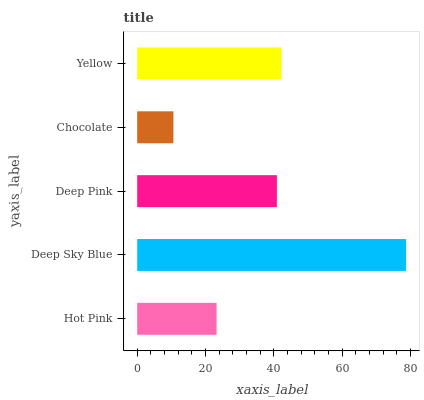Is Chocolate the minimum?
Answer yes or no. Yes. Is Deep Sky Blue the maximum?
Answer yes or no. Yes. Is Deep Pink the minimum?
Answer yes or no. No. Is Deep Pink the maximum?
Answer yes or no. No. Is Deep Sky Blue greater than Deep Pink?
Answer yes or no. Yes. Is Deep Pink less than Deep Sky Blue?
Answer yes or no. Yes. Is Deep Pink greater than Deep Sky Blue?
Answer yes or no. No. Is Deep Sky Blue less than Deep Pink?
Answer yes or no. No. Is Deep Pink the high median?
Answer yes or no. Yes. Is Deep Pink the low median?
Answer yes or no. Yes. Is Yellow the high median?
Answer yes or no. No. Is Chocolate the low median?
Answer yes or no. No. 